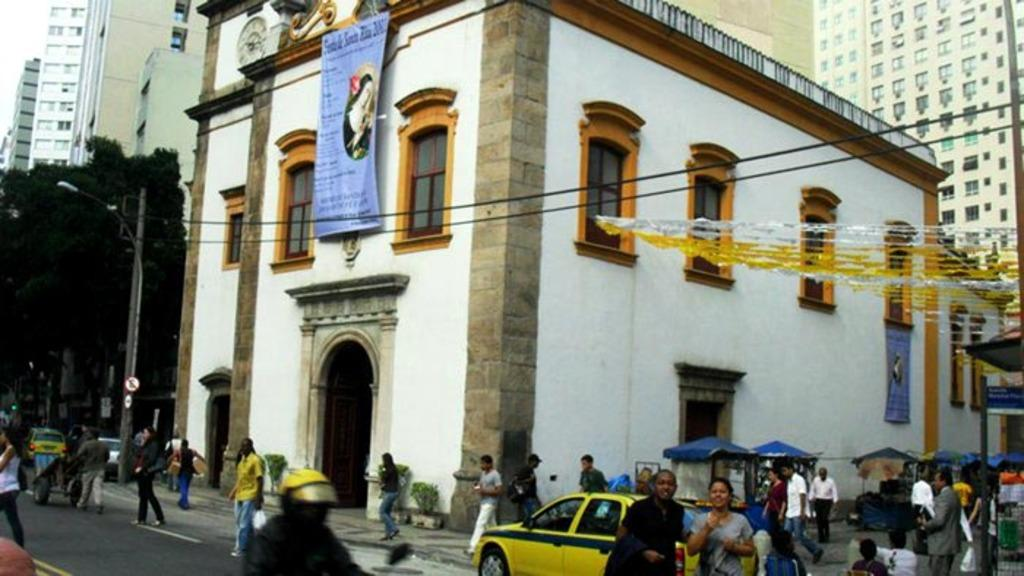What types of living organisms can be seen in the image? People and plants are visible in the image. What type of vehicles can be seen in the image? Cars are visible in the image. What type of structures can be seen in the image? Poles, buildings, and stalls are visible in the image. What type of natural elements can be seen in the image? Trees are visible in the image. What type of signage can be seen in the image? Banners and boards are visible in the image. What type of decorative objects can be seen in the image? Decorative objects are visible in the image. What type of pathway can be seen in the image? There is a road visible in the image. How many spiders are crawling on the banners in the image? There are no spiders visible in the image. What type of room is depicted in the image? The image does not show a room; it contains an outdoor scene with people, cars, plants, poles, buildings, stalls, banners, boards, decorative objects, and a road. 